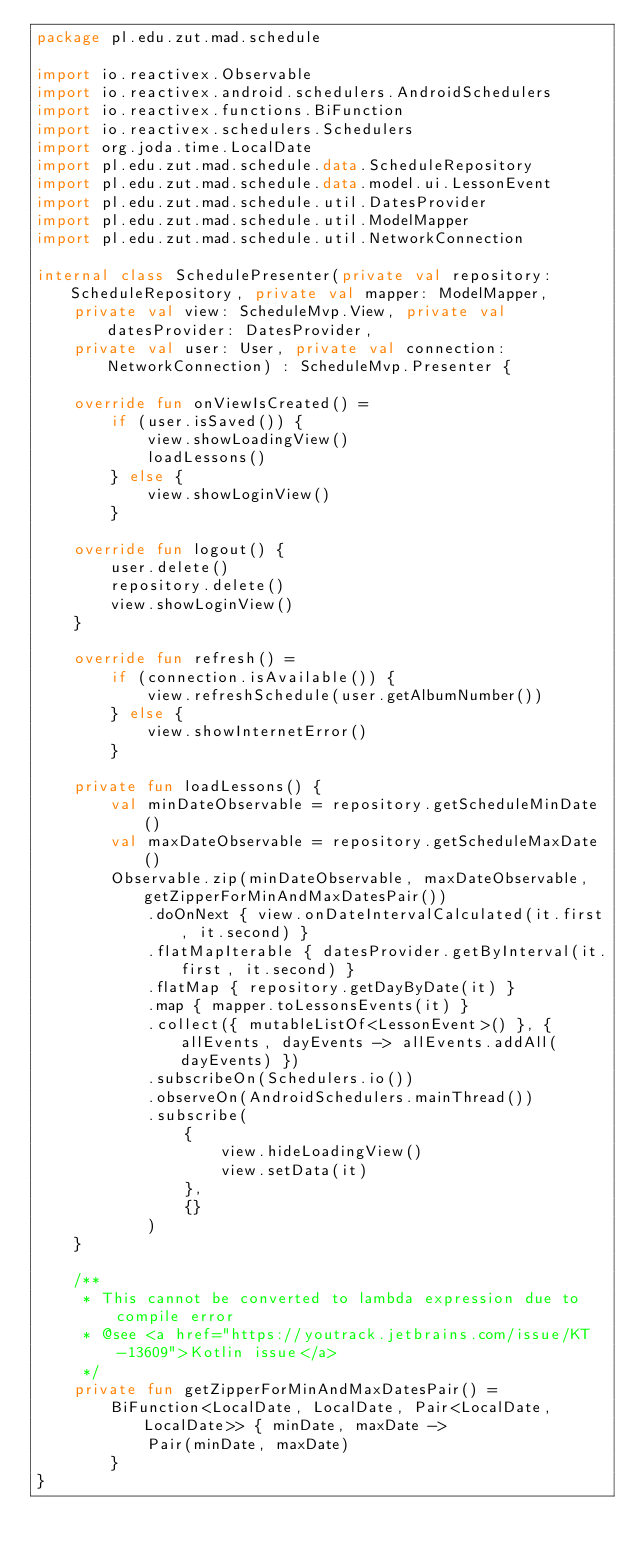<code> <loc_0><loc_0><loc_500><loc_500><_Kotlin_>package pl.edu.zut.mad.schedule

import io.reactivex.Observable
import io.reactivex.android.schedulers.AndroidSchedulers
import io.reactivex.functions.BiFunction
import io.reactivex.schedulers.Schedulers
import org.joda.time.LocalDate
import pl.edu.zut.mad.schedule.data.ScheduleRepository
import pl.edu.zut.mad.schedule.data.model.ui.LessonEvent
import pl.edu.zut.mad.schedule.util.DatesProvider
import pl.edu.zut.mad.schedule.util.ModelMapper
import pl.edu.zut.mad.schedule.util.NetworkConnection

internal class SchedulePresenter(private val repository: ScheduleRepository, private val mapper: ModelMapper,
    private val view: ScheduleMvp.View, private val datesProvider: DatesProvider,
    private val user: User, private val connection: NetworkConnection) : ScheduleMvp.Presenter {

    override fun onViewIsCreated() =
        if (user.isSaved()) {
            view.showLoadingView()
            loadLessons()
        } else {
            view.showLoginView()
        }

    override fun logout() {
        user.delete()
        repository.delete()
        view.showLoginView()
    }

    override fun refresh() =
        if (connection.isAvailable()) {
            view.refreshSchedule(user.getAlbumNumber())
        } else {
            view.showInternetError()
        }

    private fun loadLessons() {
        val minDateObservable = repository.getScheduleMinDate()
        val maxDateObservable = repository.getScheduleMaxDate()
        Observable.zip(minDateObservable, maxDateObservable, getZipperForMinAndMaxDatesPair())
            .doOnNext { view.onDateIntervalCalculated(it.first, it.second) }
            .flatMapIterable { datesProvider.getByInterval(it.first, it.second) }
            .flatMap { repository.getDayByDate(it) }
            .map { mapper.toLessonsEvents(it) }
            .collect({ mutableListOf<LessonEvent>() }, { allEvents, dayEvents -> allEvents.addAll(dayEvents) })
            .subscribeOn(Schedulers.io())
            .observeOn(AndroidSchedulers.mainThread())
            .subscribe(
                {
                    view.hideLoadingView()
                    view.setData(it)
                },
                {}
            )
    }

    /**
     * This cannot be converted to lambda expression due to compile error
     * @see <a href="https://youtrack.jetbrains.com/issue/KT-13609">Kotlin issue</a>
     */
    private fun getZipperForMinAndMaxDatesPair() =
        BiFunction<LocalDate, LocalDate, Pair<LocalDate, LocalDate>> { minDate, maxDate ->
            Pair(minDate, maxDate)
        }
}
</code> 